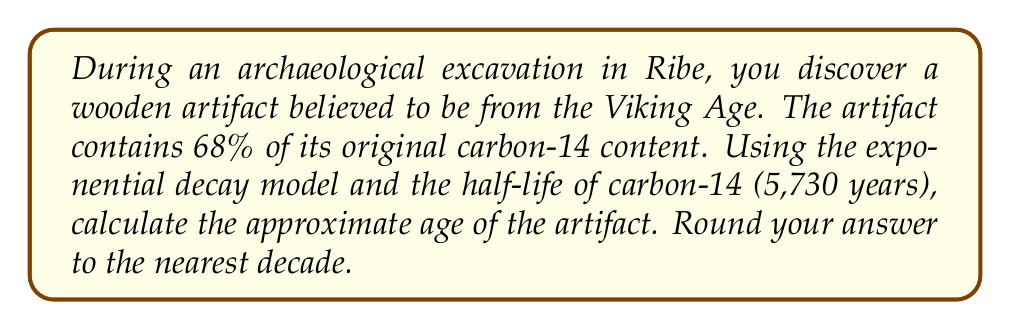What is the answer to this math problem? Let's approach this step-by-step using the exponential decay model:

1) The exponential decay formula is:

   $$N(t) = N_0 e^{-\lambda t}$$

   Where:
   $N(t)$ is the amount remaining after time $t$
   $N_0$ is the initial amount
   $\lambda$ is the decay constant
   $t$ is the time elapsed

2) We know that $N(t)/N_0 = 0.68$ (68% remaining)

3) The decay constant $\lambda$ is related to the half-life $T_{1/2}$ by:

   $$\lambda = \frac{\ln(2)}{T_{1/2}}$$

4) Substituting the half-life of carbon-14:

   $$\lambda = \frac{\ln(2)}{5730} \approx 0.000121$$

5) Now we can set up our equation:

   $$0.68 = e^{-0.000121t}$$

6) Taking the natural log of both sides:

   $$\ln(0.68) = -0.000121t$$

7) Solving for $t$:

   $$t = \frac{\ln(0.68)}{-0.000121} \approx 3170.9$$

8) Rounding to the nearest decade:

   $$t \approx 3170 \text{ years}$$
Answer: 3170 years 